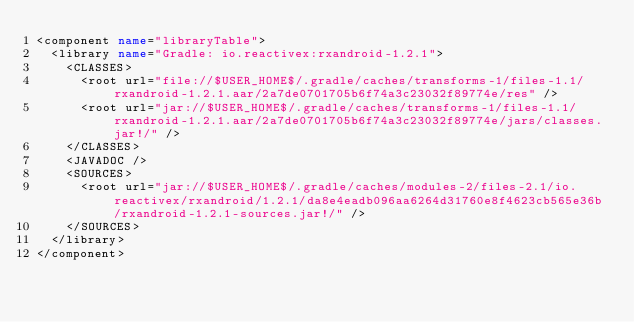<code> <loc_0><loc_0><loc_500><loc_500><_XML_><component name="libraryTable">
  <library name="Gradle: io.reactivex:rxandroid-1.2.1">
    <CLASSES>
      <root url="file://$USER_HOME$/.gradle/caches/transforms-1/files-1.1/rxandroid-1.2.1.aar/2a7de0701705b6f74a3c23032f89774e/res" />
      <root url="jar://$USER_HOME$/.gradle/caches/transforms-1/files-1.1/rxandroid-1.2.1.aar/2a7de0701705b6f74a3c23032f89774e/jars/classes.jar!/" />
    </CLASSES>
    <JAVADOC />
    <SOURCES>
      <root url="jar://$USER_HOME$/.gradle/caches/modules-2/files-2.1/io.reactivex/rxandroid/1.2.1/da8e4eadb096aa6264d31760e8f4623cb565e36b/rxandroid-1.2.1-sources.jar!/" />
    </SOURCES>
  </library>
</component></code> 